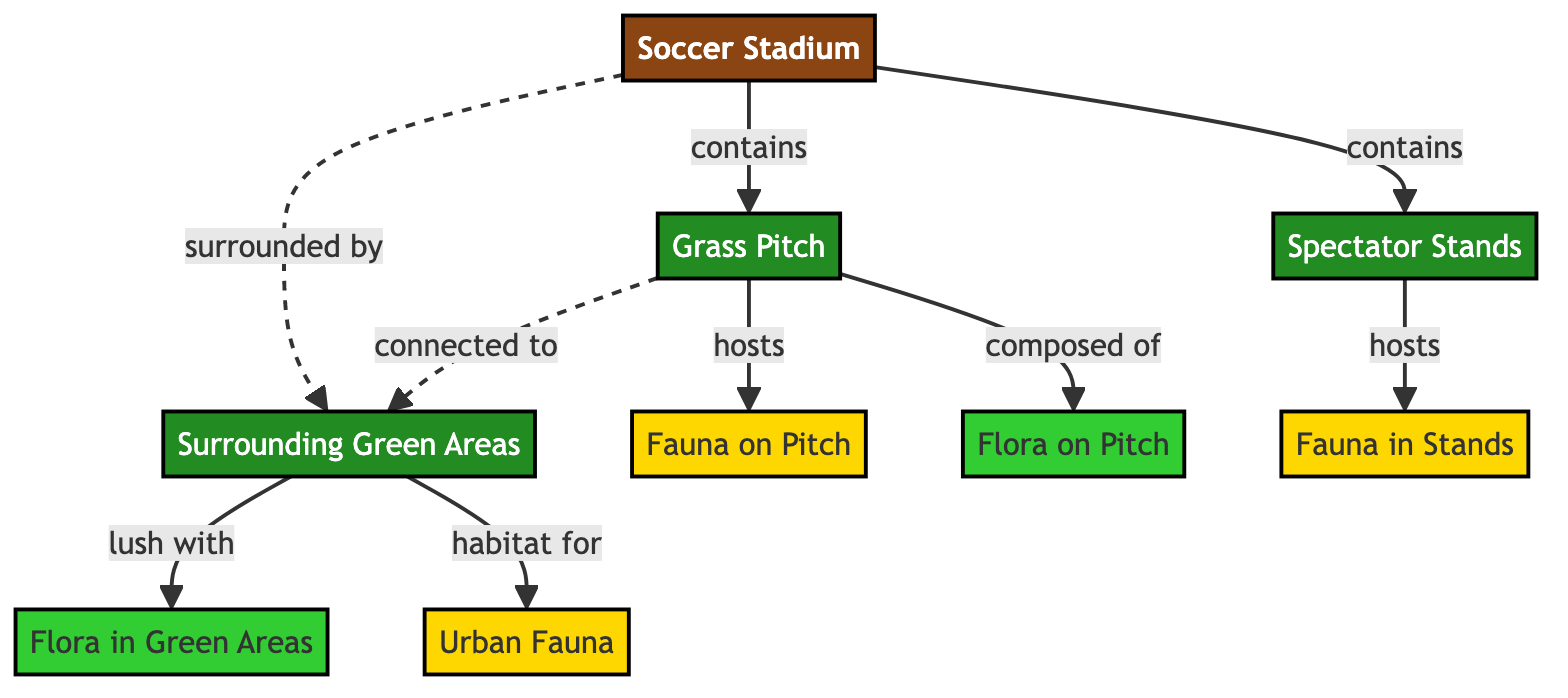What is the central structure depicted in the diagram? The diagram prominently features the "Soccer Stadium" node, which is the main focus and serves as the central structure from which all other elements are connected.
Answer: Soccer Stadium How many types of fauna are represented in the diagram? The diagram indicates three distinct instances of fauna: "Fauna on Pitch," "Fauna in Stands," and "Urban Fauna," giving a total of three types.
Answer: 3 What type of flora is described as surrounding the stadium? The diagram specifies "Flora in Green Areas" as the type of flora that is lush and surrounding the stadium, indicating a rich plant life in these areas.
Answer: Flora in Green Areas Which part of the stadium hosts urban wildlife? The "Green Areas" surrounding the stadium serve as a habitat for "Urban Fauna," indicating that wildlife is supported in these spaces rather than directly in the stadium structures.
Answer: Green Areas How does the pitch relate to the surrounding green areas? The diagram establishes that the "Pitch" is "connected to" the "Green Areas," indicating a relationship where the natural environment surrounding the stadium ties back into the play area.
Answer: connected to What is the relationship between the "Spectator Stands" and "Fauna in Stands"? The "Stands" are linked specifically to "Fauna in Stands," suggesting that this area is home to certain fauna, perhaps birds or small animals that utilize this space.
Answer: hosts Which component is depicted as having both flora and fauna? The diagram illustrates that the "Pitch" hosts both "Flora on Pitch" and "Fauna on Pitch," indicating that this grassy area is rich in biodiversity.
Answer: Pitch What describes the relationship between the stadium and its surrounding areas? The relationship depicted shows that the "Stadium" is "surrounded by" "Green Areas," indicating that vegetation and wildlife habitat encircle the stadium, creating a natural buffer or ecosystem.
Answer: surrounded by How many elements comprise the overall ecosystem in this diagram? Counting all the unique nodes visible in the diagram, which include the stadium, pitch, stands, green areas, and various types of fauna and flora, leads to a total of seven distinct elements in the ecosystem.
Answer: 7 